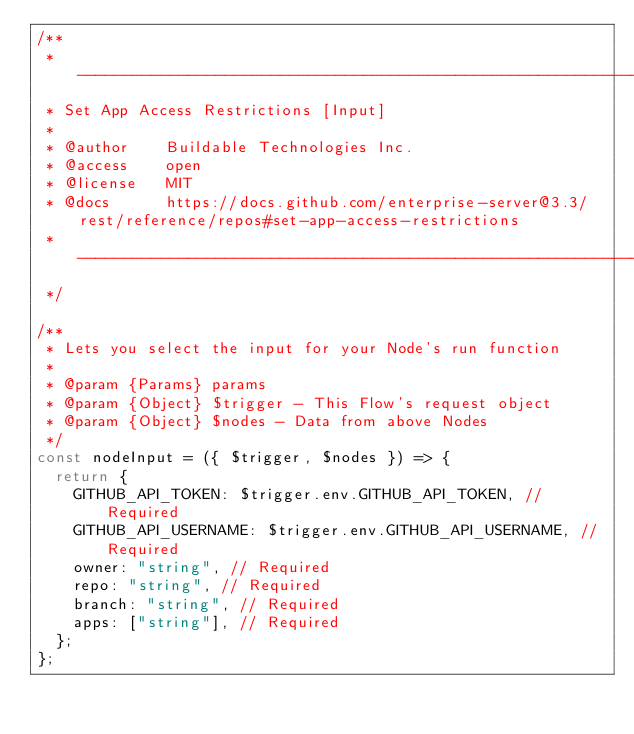Convert code to text. <code><loc_0><loc_0><loc_500><loc_500><_JavaScript_>/**
 * ----------------------------------------------------------------------------------------------------
 * Set App Access Restrictions [Input]
 *
 * @author    Buildable Technologies Inc.
 * @access    open
 * @license   MIT
 * @docs      https://docs.github.com/enterprise-server@3.3/rest/reference/repos#set-app-access-restrictions
 * ----------------------------------------------------------------------------------------------------
 */

/**
 * Lets you select the input for your Node's run function
 *
 * @param {Params} params
 * @param {Object} $trigger - This Flow's request object
 * @param {Object} $nodes - Data from above Nodes
 */
const nodeInput = ({ $trigger, $nodes }) => {
  return {
    GITHUB_API_TOKEN: $trigger.env.GITHUB_API_TOKEN, // Required
    GITHUB_API_USERNAME: $trigger.env.GITHUB_API_USERNAME, // Required
    owner: "string", // Required
    repo: "string", // Required
    branch: "string", // Required
    apps: ["string"], // Required
  };
};
</code> 